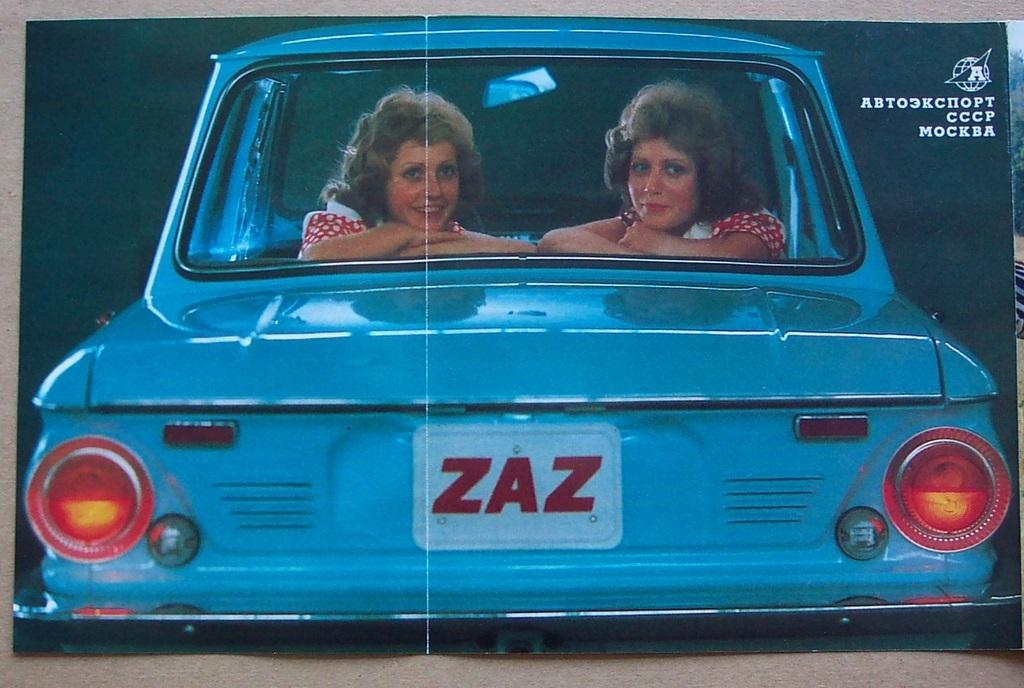How many people are in the image? There are 2 women in the image. What are the women doing in the image? The women are sitting in a blue car. What can be seen on the car's registration plate? The registration plate on the car has "zazn" written on it. What type of watch is the woman in the middle wearing in the image? There is no woman in the middle, and no watches are visible in the image. 